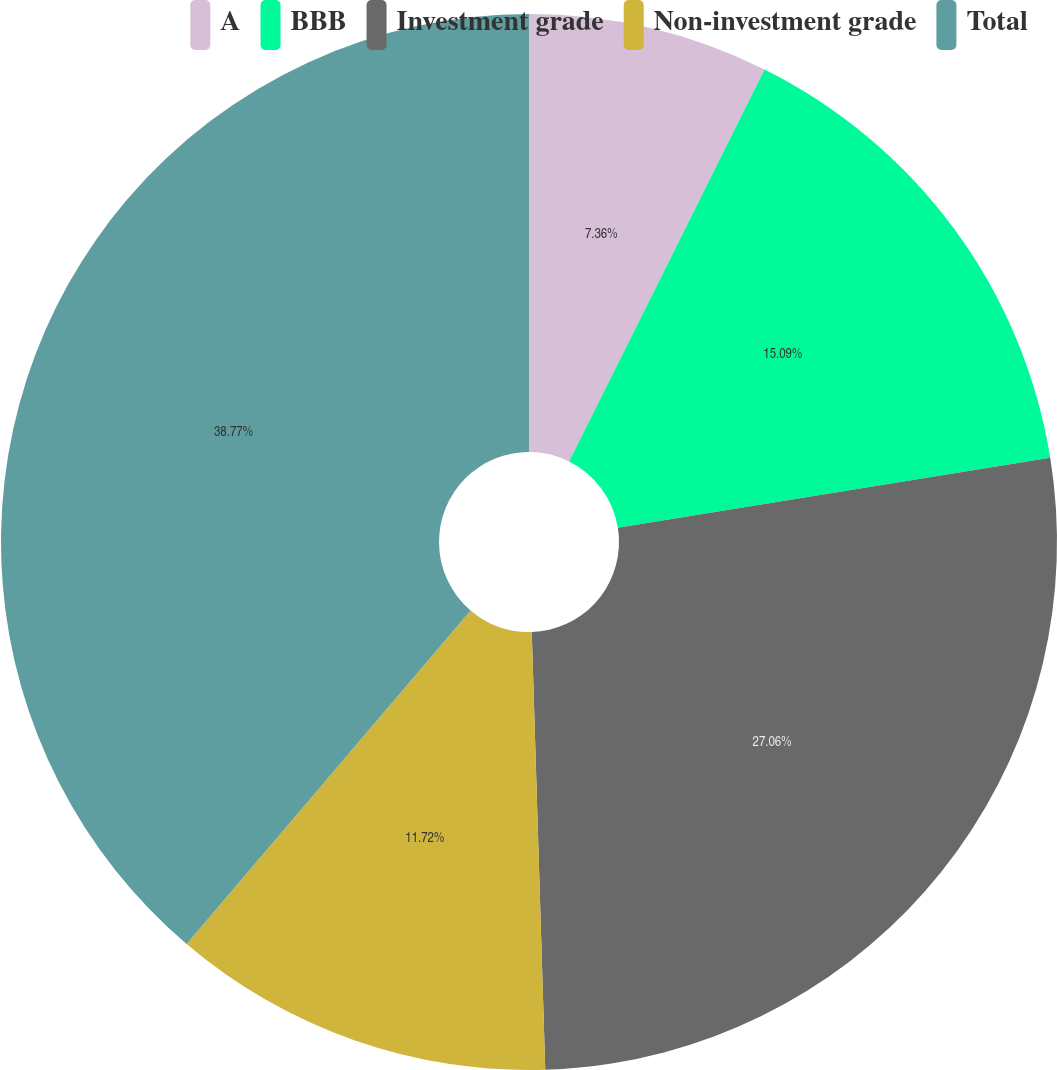Convert chart to OTSL. <chart><loc_0><loc_0><loc_500><loc_500><pie_chart><fcel>A<fcel>BBB<fcel>Investment grade<fcel>Non-investment grade<fcel>Total<nl><fcel>7.36%<fcel>15.09%<fcel>27.06%<fcel>11.72%<fcel>38.77%<nl></chart> 